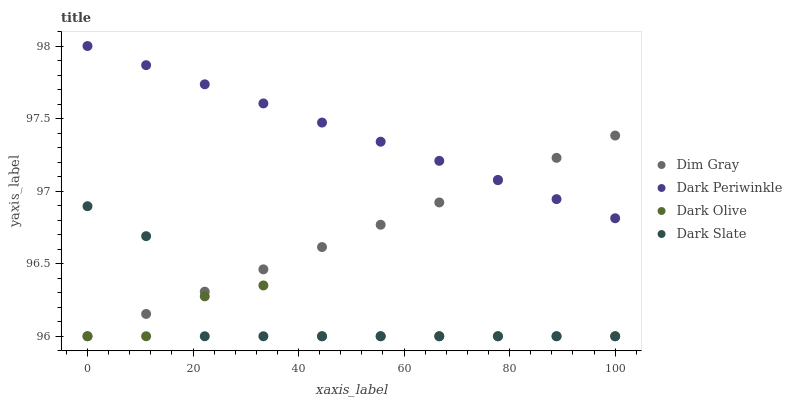Does Dark Olive have the minimum area under the curve?
Answer yes or no. Yes. Does Dark Periwinkle have the maximum area under the curve?
Answer yes or no. Yes. Does Dark Slate have the minimum area under the curve?
Answer yes or no. No. Does Dark Slate have the maximum area under the curve?
Answer yes or no. No. Is Dark Periwinkle the smoothest?
Answer yes or no. Yes. Is Dark Olive the roughest?
Answer yes or no. Yes. Is Dark Slate the smoothest?
Answer yes or no. No. Is Dark Slate the roughest?
Answer yes or no. No. Does Dark Olive have the lowest value?
Answer yes or no. Yes. Does Dark Periwinkle have the lowest value?
Answer yes or no. No. Does Dark Periwinkle have the highest value?
Answer yes or no. Yes. Does Dark Slate have the highest value?
Answer yes or no. No. Is Dark Olive less than Dark Periwinkle?
Answer yes or no. Yes. Is Dark Periwinkle greater than Dark Olive?
Answer yes or no. Yes. Does Dark Olive intersect Dark Slate?
Answer yes or no. Yes. Is Dark Olive less than Dark Slate?
Answer yes or no. No. Is Dark Olive greater than Dark Slate?
Answer yes or no. No. Does Dark Olive intersect Dark Periwinkle?
Answer yes or no. No. 